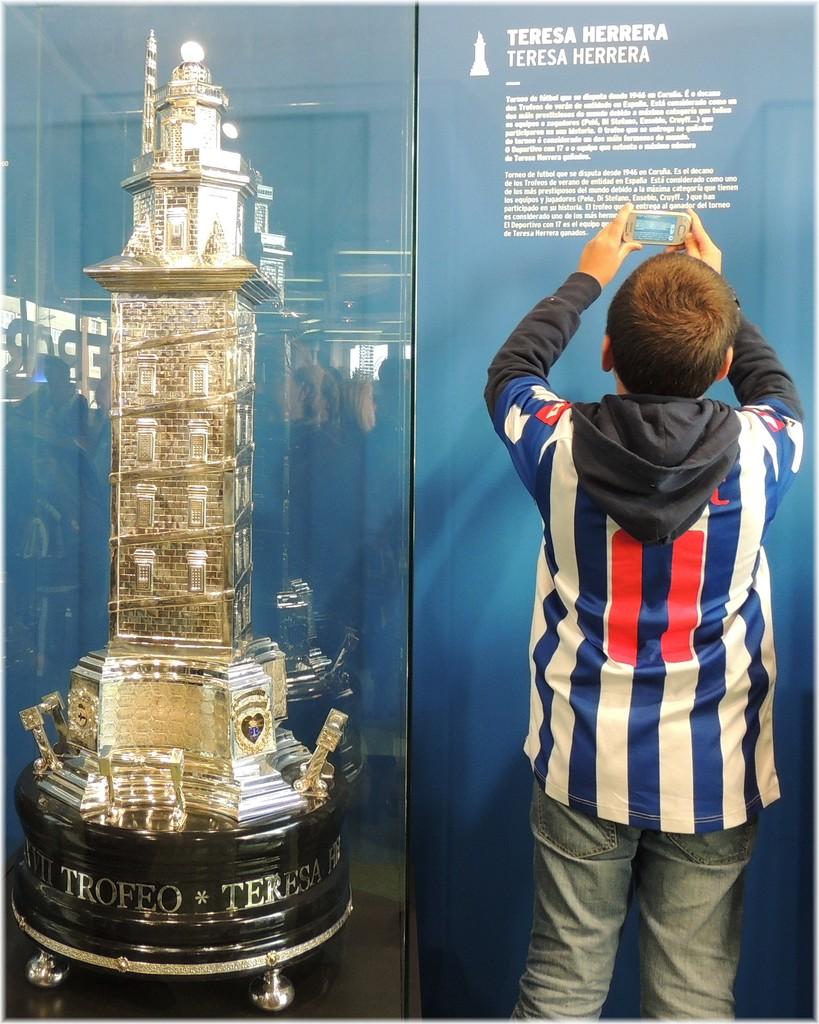What name is printed at the top of the glass?
Your response must be concise. Teresa herrera. What does it write in capital letters?
Keep it short and to the point. Teresa herrera. 